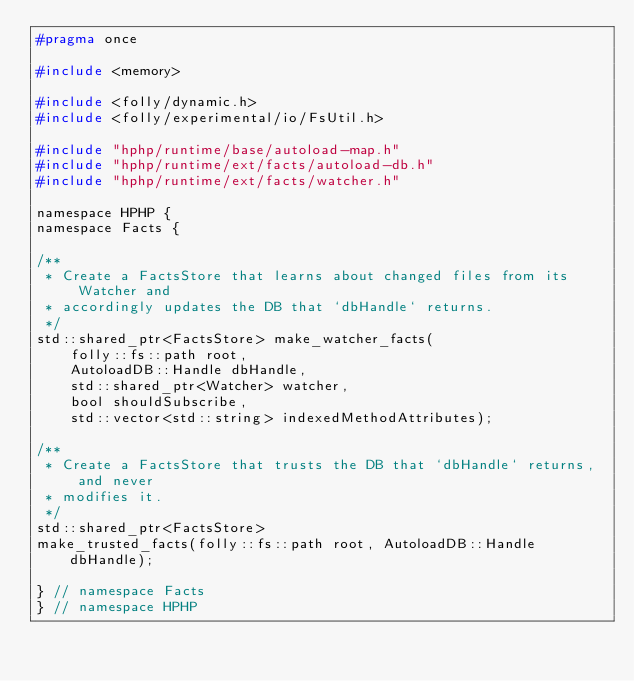Convert code to text. <code><loc_0><loc_0><loc_500><loc_500><_C_>#pragma once

#include <memory>

#include <folly/dynamic.h>
#include <folly/experimental/io/FsUtil.h>

#include "hphp/runtime/base/autoload-map.h"
#include "hphp/runtime/ext/facts/autoload-db.h"
#include "hphp/runtime/ext/facts/watcher.h"

namespace HPHP {
namespace Facts {

/**
 * Create a FactsStore that learns about changed files from its Watcher and
 * accordingly updates the DB that `dbHandle` returns.
 */
std::shared_ptr<FactsStore> make_watcher_facts(
    folly::fs::path root,
    AutoloadDB::Handle dbHandle,
    std::shared_ptr<Watcher> watcher,
    bool shouldSubscribe,
    std::vector<std::string> indexedMethodAttributes);

/**
 * Create a FactsStore that trusts the DB that `dbHandle` returns, and never
 * modifies it.
 */
std::shared_ptr<FactsStore>
make_trusted_facts(folly::fs::path root, AutoloadDB::Handle dbHandle);

} // namespace Facts
} // namespace HPHP
</code> 